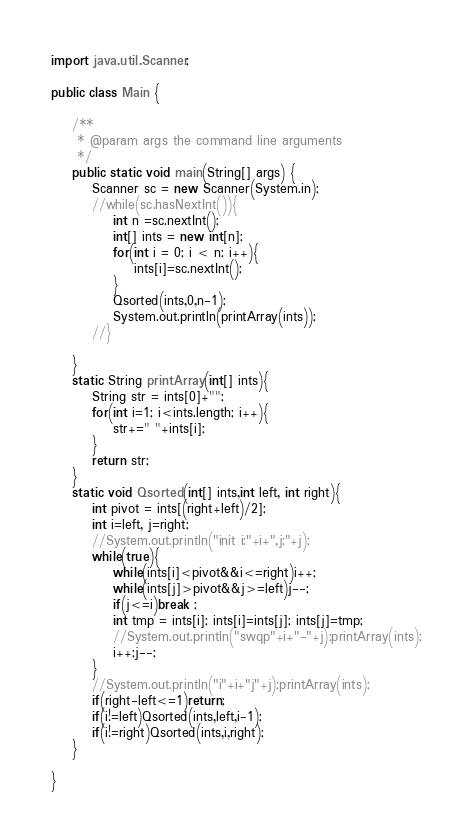Convert code to text. <code><loc_0><loc_0><loc_500><loc_500><_Java_>

import java.util.Scanner;

public class Main {

    /**
     * @param args the command line arguments
     */
    public static void main(String[] args) {
        Scanner sc = new Scanner(System.in);
        //while(sc.hasNextInt()){
            int n =sc.nextInt();
            int[] ints = new int[n];
            for(int i = 0; i < n; i++){
                ints[i]=sc.nextInt();
            }
            Qsorted(ints,0,n-1);
            System.out.println(printArray(ints));
        //}
        
    }
    static String printArray(int[] ints){
        String str = ints[0]+"";
        for(int i=1; i<ints.length; i++){
            str+=" "+ints[i];
        }
        return str;
    }
    static void Qsorted(int[] ints,int left, int right){
        int pivot = ints[(right+left)/2];
        int i=left, j=right;
        //System.out.println("init i:"+i+",j:"+j);
        while(true){
            while(ints[i]<pivot&&i<=right)i++;
            while(ints[j]>pivot&&j>=left)j--;
            if(j<=i)break ;
            int tmp = ints[i]; ints[i]=ints[j]; ints[j]=tmp;
            //System.out.println("swqp"+i+"-"+j);printArray(ints);
            i++;j--;        
        }
        //System.out.println("i"+i+"j"+j);printArray(ints);
        if(right-left<=1)return;
        if(i!=left)Qsorted(ints,left,i-1);
        if(i!=right)Qsorted(ints,i,right);
    }

}</code> 